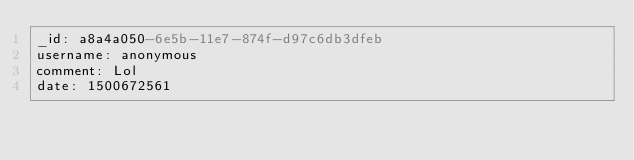<code> <loc_0><loc_0><loc_500><loc_500><_YAML_>_id: a8a4a050-6e5b-11e7-874f-d97c6db3dfeb
username: anonymous
comment: Lol
date: 1500672561
</code> 